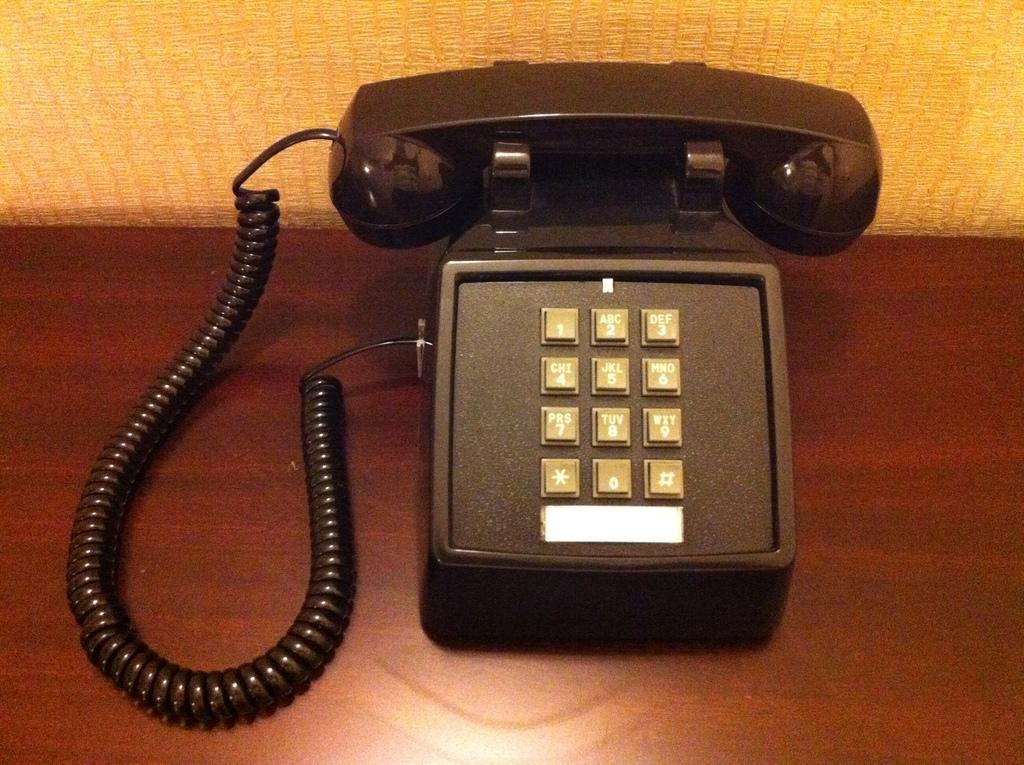Can you describe this image briefly? In this image I can see the telephone on the brown color surface. I can see the yellow color background. 